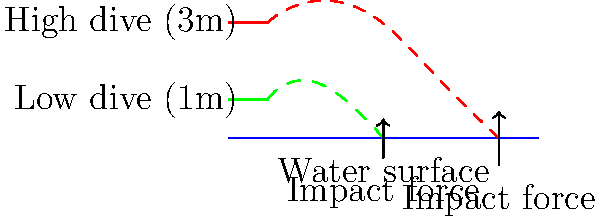In your Baywatch days, you might have seen divers perform from different heights. Consider a diver jumping from a 1m board and a 3m board. How does the impact force change, and what factors contribute to this difference? To understand the difference in impact force between a 1m and 3m dive, let's break it down step-by-step:

1. Gravitational Potential Energy:
   The initial gravitational potential energy is given by $E_p = mgh$, where $m$ is mass, $g$ is gravitational acceleration, and $h$ is height.

2. Kinetic Energy at Impact:
   As the diver falls, potential energy converts to kinetic energy. At impact, $E_k = \frac{1}{2}mv^2 = mgh$

3. Velocity at Impact:
   Rearranging the kinetic energy equation, we get $v = \sqrt{2gh}$

4. For a 1m dive: $v_1 = \sqrt{2 \cdot 9.8 \cdot 1} \approx 4.43$ m/s
   For a 3m dive: $v_3 = \sqrt{2 \cdot 9.8 \cdot 3} \approx 7.67$ m/s

5. Impact Force:
   The impact force is related to the change in momentum over time: $F = \frac{\Delta p}{\Delta t} = \frac{m(v_f - v_i)}{\Delta t}$

6. Assuming the same stopping distance for both dives, the time of impact is proportional to the velocity: $\Delta t \propto \frac{1}{v}$

7. Therefore, the impact force is proportional to $v^2$:
   $F \propto mv^2$

8. Comparing the two dives:
   $\frac{F_3}{F_1} = \frac{v_3^2}{v_1^2} = \frac{7.67^2}{4.43^2} \approx 3$

The impact force from the 3m dive is approximately 3 times greater than the 1m dive. Factors contributing to this difference include the increased height, resulting in higher velocity at impact and shorter impact time.
Answer: The impact force from the 3m dive is approximately 3 times greater than the 1m dive due to increased velocity at impact. 